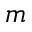<formula> <loc_0><loc_0><loc_500><loc_500>m</formula> 